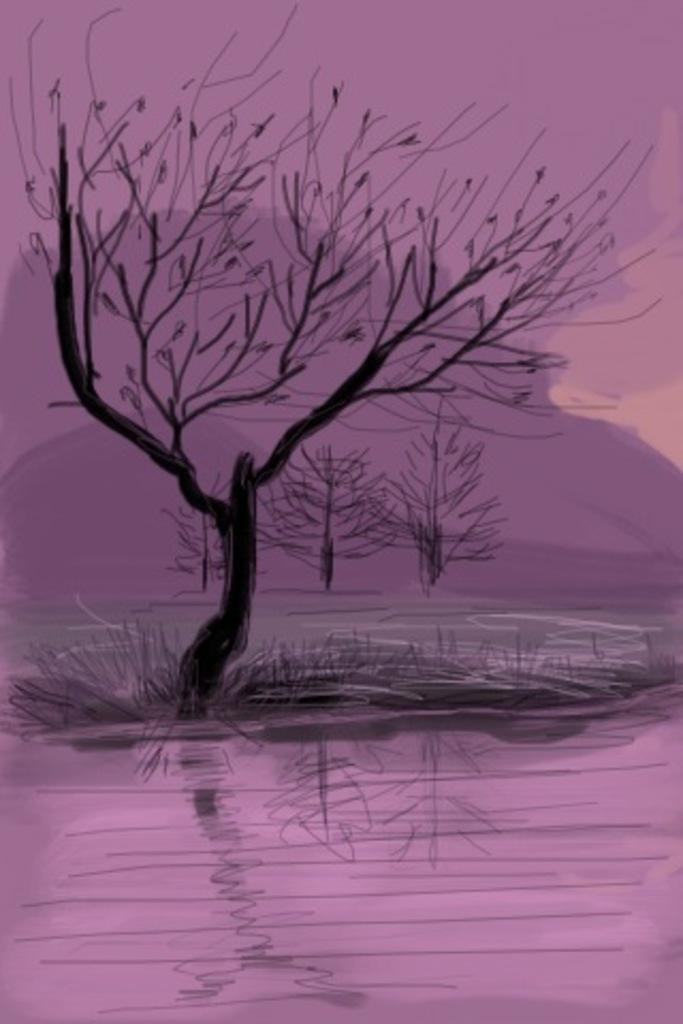What is the main subject of the painting in the image? There is a painting of a tree in the image. Where is the tree located in the painting? The tree is in the middle of a river. What can be seen in the background of the painting? There are trees and mountains in the background of the image, and the sky is also visible. What type of popcorn is being served to the horses in the image? There are no horses or popcorn present in the image; it features a painting of a tree in the middle of a river with trees, mountains, and the sky in the background. 